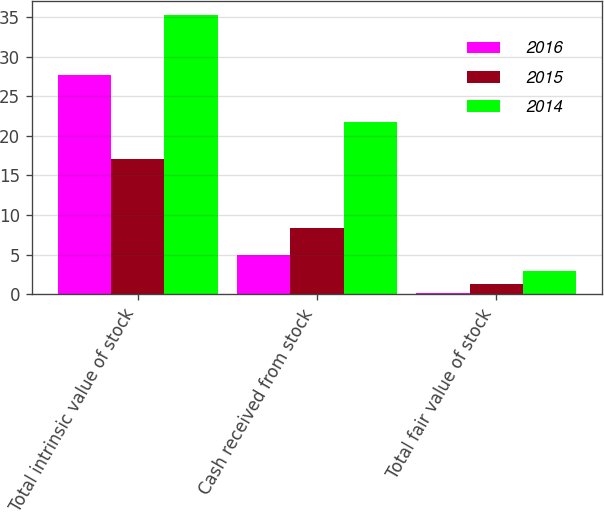Convert chart. <chart><loc_0><loc_0><loc_500><loc_500><stacked_bar_chart><ecel><fcel>Total intrinsic value of stock<fcel>Cash received from stock<fcel>Total fair value of stock<nl><fcel>2016<fcel>27.7<fcel>4.9<fcel>0.1<nl><fcel>2015<fcel>17.1<fcel>8.3<fcel>1.3<nl><fcel>2014<fcel>35.2<fcel>21.8<fcel>2.9<nl></chart> 